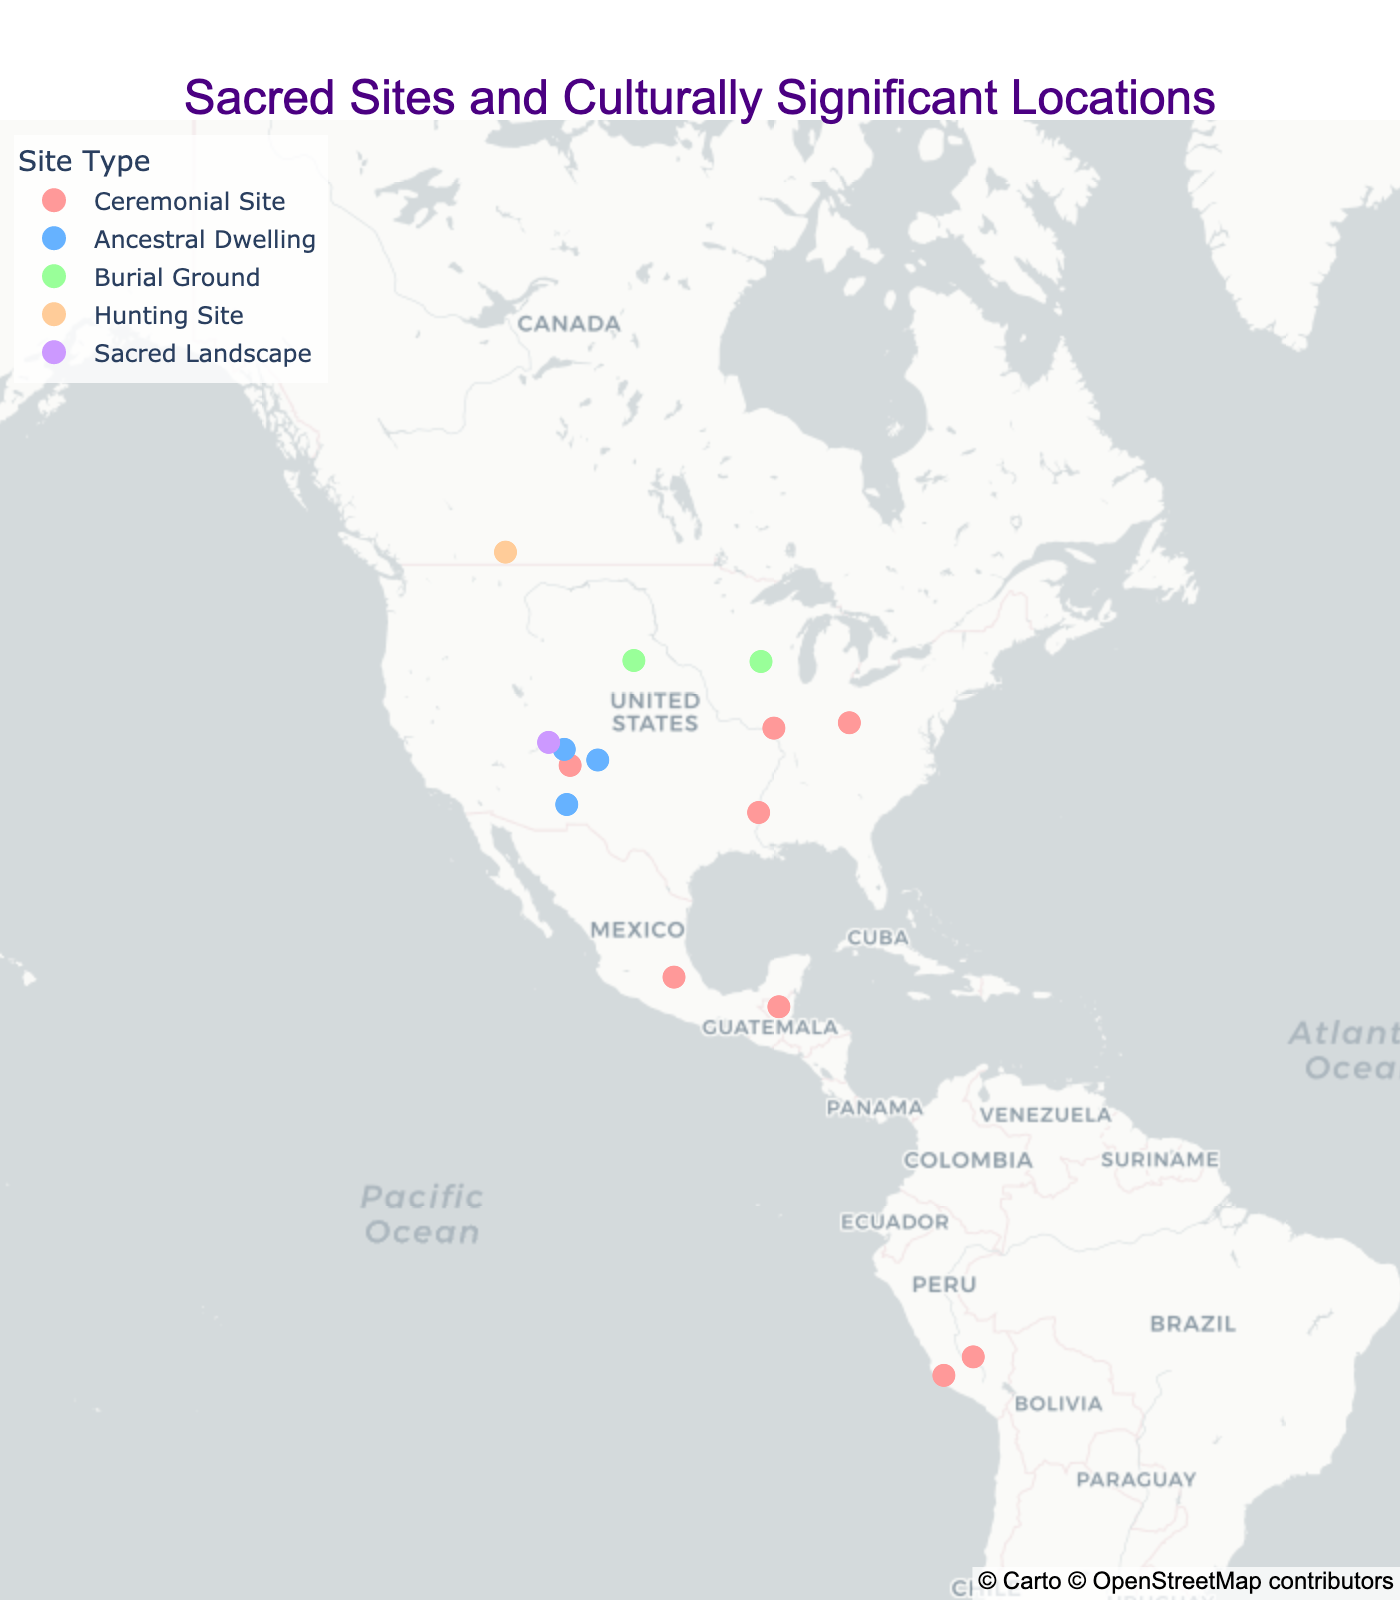Which site is located the furthest north? To find the furthest north site, locate the marker with the highest latitude on the map. Based on the locations provided, Head-Smashed-In Buffalo Jump has the highest latitude at 49.7053.
Answer: Head-Smashed-In Buffalo Jump How many sites are labelled as 'Ceremonial Site'? Count the number of markers colored in the shade corresponding to 'Ceremonial Site' (#FF9999). There are six such markers.
Answer: 6 Which tribes are associated with 'Ancestral Dwelling' sites? Identify the markers labeled as 'Ancestral Dwelling' and check the hover data for the tribe information. The tribes listed are Ancestral Puebloans for Mesa Verde and Chaco Canyon, Puebloan for Taos Pueblo, Mogollon for Gila Cliff Dwellings.
Answer: Ancestral Puebloans, Puebloan, Mogollon Are there more 'Ceremonial Sites' or 'Burial Grounds'? Count the number of markers for both 'Ceremonial Sites' and 'Burial Grounds'. Ceremonial Sites have six markers, and Burial Grounds have two. Thus, there are more Ceremonial Sites.
Answer: Ceremonial Sites Is there any site that appears to be located on a different continent? Check if any markers are located far from the clustered group in North America. Machu Picchu and Nazca Lines are noticeably in South America.
Answer: Yes Which site has the closest latitude to the equator? The equator is at latitude 0. The site with the latitude closest to 0 would be checked. Machu Picchu has a latitude of -13.1631, and Nazca Lines has -14.7389, making Machu Picchu the closer one.
Answer: Machu Picchu Which type of site is spread out the most geographically? Check the spread of the color markers for each type. Ceremonial Sites appear to have a wide geographical distribution, from North to South America.
Answer: Ceremonial Sites What is the southernmost site? The southernmost site will have the lowest latitude value. The site with the lowest latitude is Nazca Lines at -14.7389.
Answer: Nazca Lines How many distinct types of sites are represented? Identify the distinct colors (site types) in the legend of the map. There are five site types: Ceremonial Site, Ancestral Dwelling, Burial Ground, Hunting Site, and Sacred Landscape.
Answer: 5 